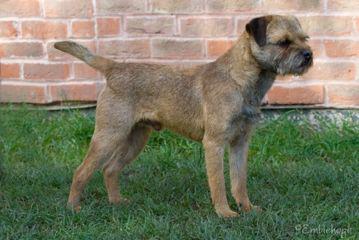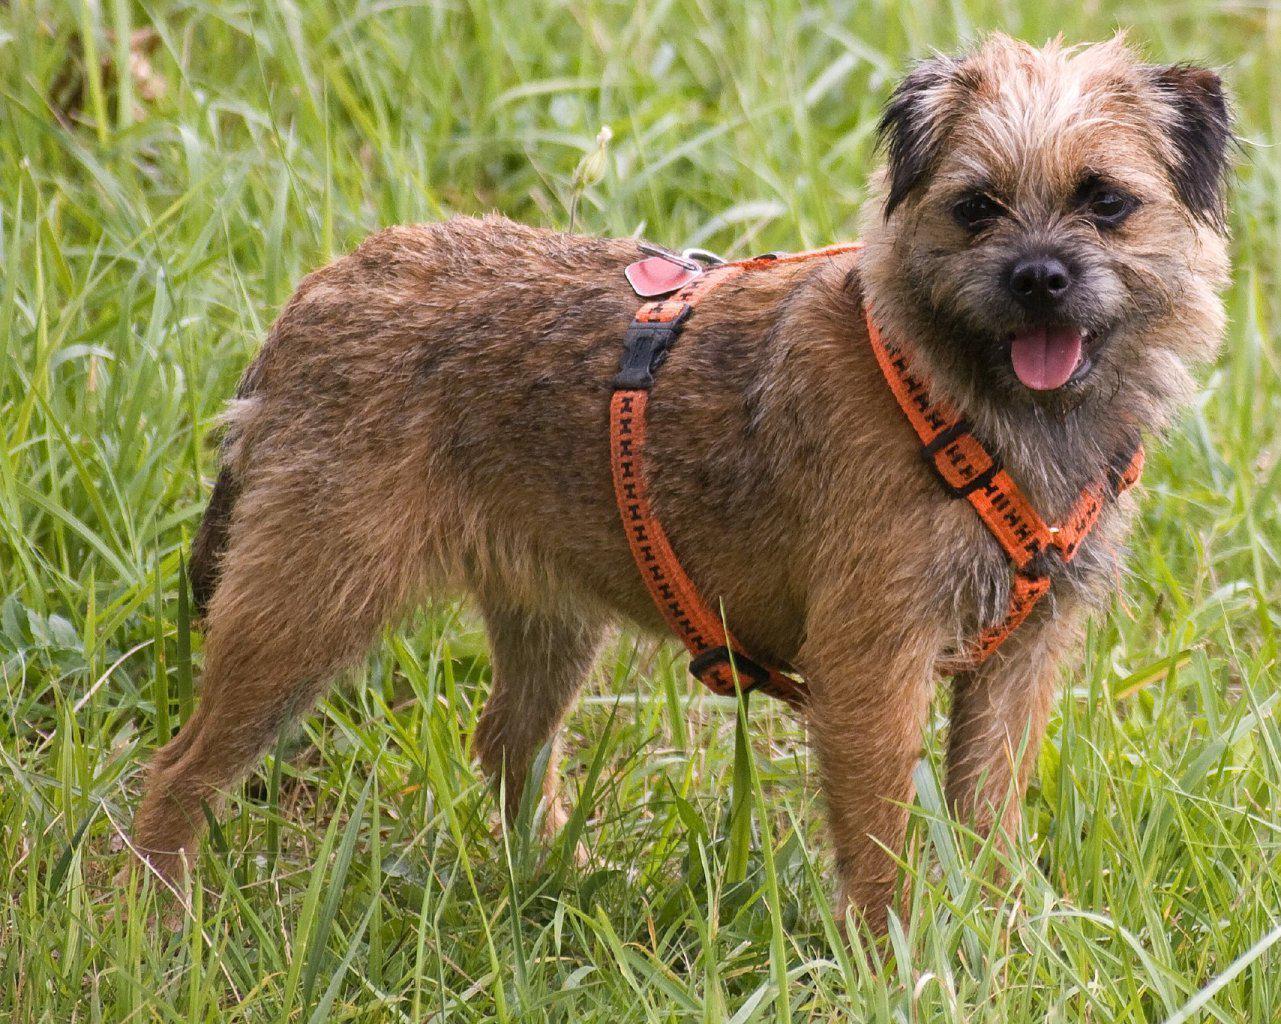The first image is the image on the left, the second image is the image on the right. For the images displayed, is the sentence "There are at least two dogs lying on a wood bench." factually correct? Answer yes or no. No. 